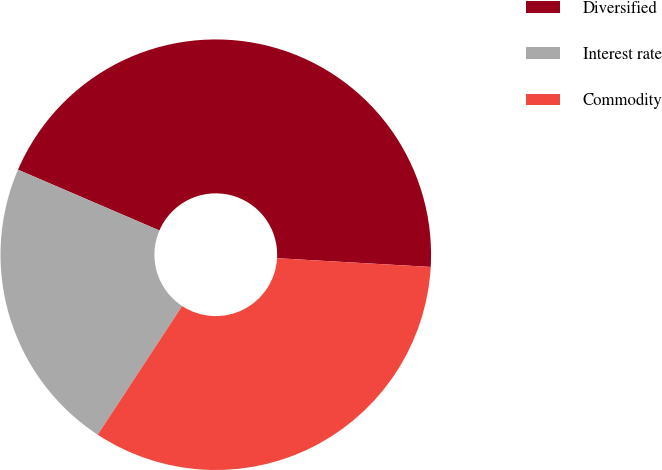Convert chart to OTSL. <chart><loc_0><loc_0><loc_500><loc_500><pie_chart><fcel>Diversified<fcel>Interest rate<fcel>Commodity<nl><fcel>44.44%<fcel>22.22%<fcel>33.33%<nl></chart> 